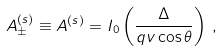Convert formula to latex. <formula><loc_0><loc_0><loc_500><loc_500>A _ { \pm } ^ { ( s ) } \equiv A ^ { ( s ) } = I _ { 0 } \left ( \frac { \Delta } { q v \cos \theta } \right ) \, ,</formula> 